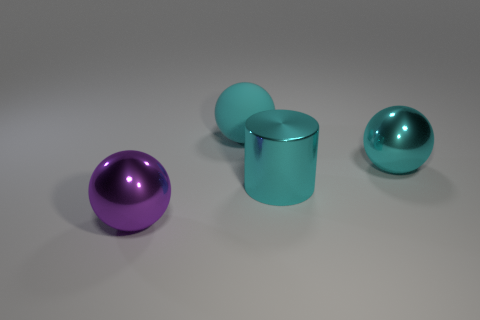Add 2 tiny purple cubes. How many objects exist? 6 Subtract all balls. How many objects are left? 1 Add 3 green matte things. How many green matte things exist? 3 Subtract 0 red cylinders. How many objects are left? 4 Subtract all tiny cyan blocks. Subtract all matte objects. How many objects are left? 3 Add 1 shiny cylinders. How many shiny cylinders are left? 2 